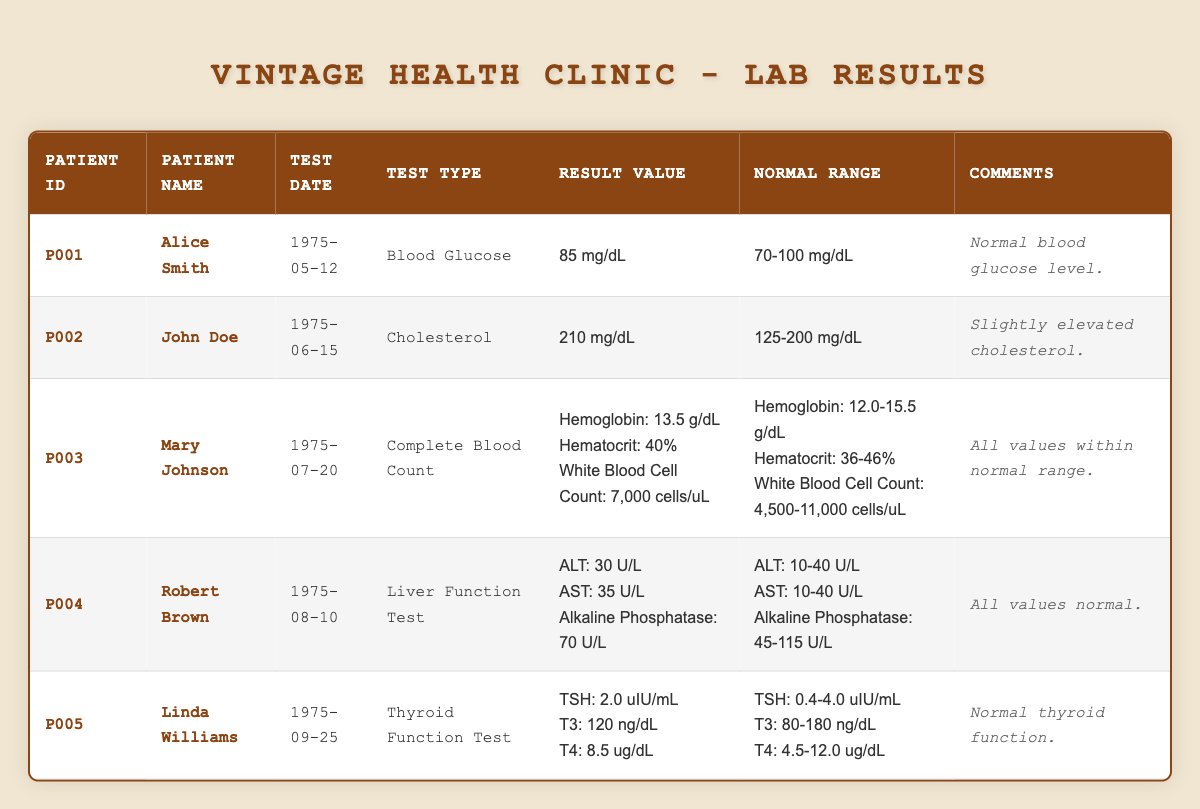What is the result value for Alice Smith's blood glucose test? The result value for Alice Smith's blood glucose test is found in the 'Result Value' column under her row, which states "85 mg/dL".
Answer: 85 mg/dL Which patient had a cholesterol level that is slightly elevated? John Doe's cholesterol result is listed as "210 mg/dL" in the 'Result Value' column, which exceeds the normal range of "125-200 mg/dL" noted in the 'Normal Range' column, confirming he had a slightly elevated cholesterol level.
Answer: John Doe Are all the results for Robert Brown's Liver Function Test within the normal range? Robert Brown's results for ALT (30 U/L), AST (35 U/L), and Alkaline Phosphatase (70 U/L) fall within their respective normal ranges (10-40 U/L, 10-40 U/L, and 45-115 U/L), confirming that all his values are normal.
Answer: Yes What is the normal range for TSH in the Thyroid Function Test? The normal range for TSH is given in Linda Williams' row under the 'Normal Range' column, which indicates "0.4-4.0 uIU/mL".
Answer: 0.4-4.0 uIU/mL How many patients had their test results evaluated as normal? Evaluating the comments of each patient: Alice Smith, Mary Johnson, Robert Brown, and Linda Williams received comments indicating normal results, totaling four patients with normal test results.
Answer: 4 What is the difference in mg/dL between the cholesterol level of John Doe and the upper limit of its normal range? John Doe has a cholesterol level of "210 mg/dL". The upper limit of the normal range is "200 mg/dL". To find the difference, subtract 200 from 210, resulting in a difference of 10 mg/dL.
Answer: 10 mg/dL Were any of the white blood cell counts outside the normal range in Mary Johnson's Complete Blood Count? Mary's white blood cell count is "7,000 cells/uL", which falls within the normal range of "4,500-11,000 cells/uL", confirming that all counts are normal and thus, none are outside the range.
Answer: No What are the individual results for Linda Williams' Thyroid Function Test? Linda Williams' results include TSH (2.0 uIU/mL), T3 (120 ng/dL), and T4 (8.5 ug/dL), which are detailed in the 'Result Value' column of her row, confirming her thyroid function was normal.
Answer: TSH: 2.0 uIU/mL, T3: 120 ng/dL, T4: 8.5 ug/dL Is the hematocrit level in Mary Johnson’s Complete Blood Count considered normal? The hematocrit level for Mary Johnson is "40%", which is within the provided normal range of "36-46%", confirming that her hematocrit level is indeed considered normal.
Answer: Yes 